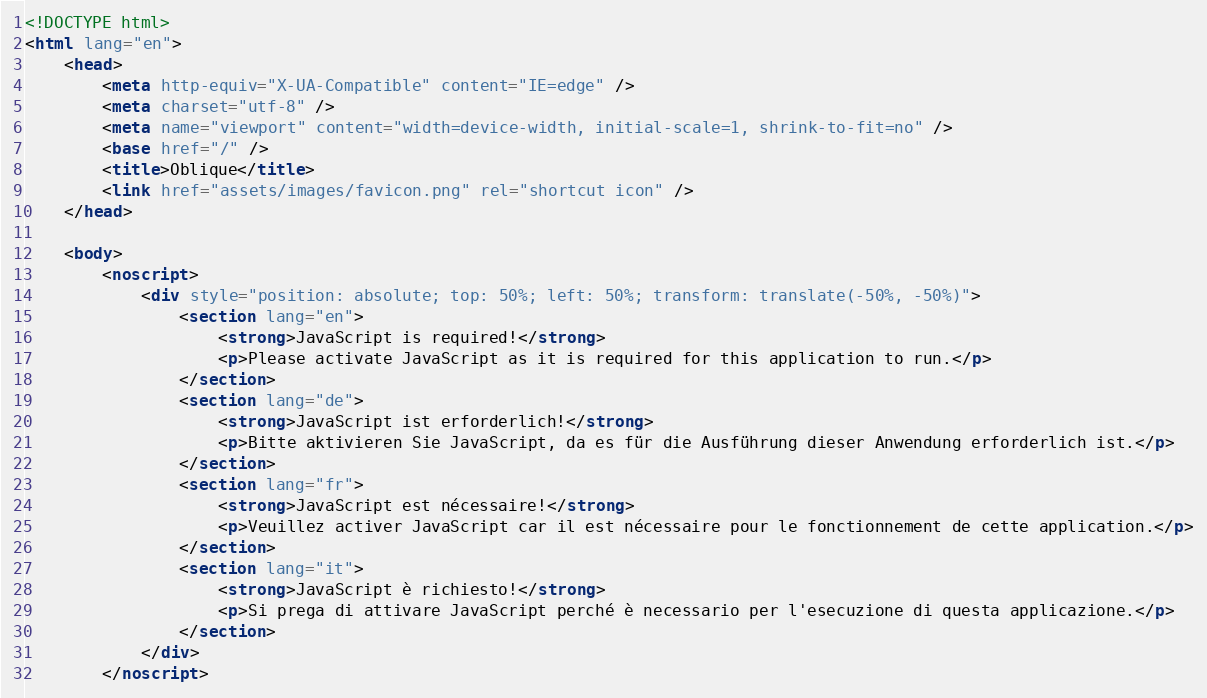<code> <loc_0><loc_0><loc_500><loc_500><_HTML_><!DOCTYPE html>
<html lang="en">
	<head>
		<meta http-equiv="X-UA-Compatible" content="IE=edge" />
		<meta charset="utf-8" />
		<meta name="viewport" content="width=device-width, initial-scale=1, shrink-to-fit=no" />
		<base href="/" />
		<title>Oblique</title>
		<link href="assets/images/favicon.png" rel="shortcut icon" />
	</head>

	<body>
		<noscript>
			<div style="position: absolute; top: 50%; left: 50%; transform: translate(-50%, -50%)">
				<section lang="en">
					<strong>JavaScript is required!</strong>
					<p>Please activate JavaScript as it is required for this application to run.</p>
				</section>
				<section lang="de">
					<strong>JavaScript ist erforderlich!</strong>
					<p>Bitte aktivieren Sie JavaScript, da es für die Ausführung dieser Anwendung erforderlich ist.</p>
				</section>
				<section lang="fr">
					<strong>JavaScript est nécessaire!</strong>
					<p>Veuillez activer JavaScript car il est nécessaire pour le fonctionnement de cette application.</p>
				</section>
				<section lang="it">
					<strong>JavaScript è richiesto!</strong>
					<p>Si prega di attivare JavaScript perché è necessario per l'esecuzione di questa applicazione.</p>
				</section>
			</div>
		</noscript></code> 